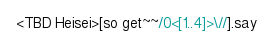<code> <loc_0><loc_0><loc_500><loc_500><_Perl_><TBD Heisei>[so get~~/0<[1..4]>\//].say</code> 